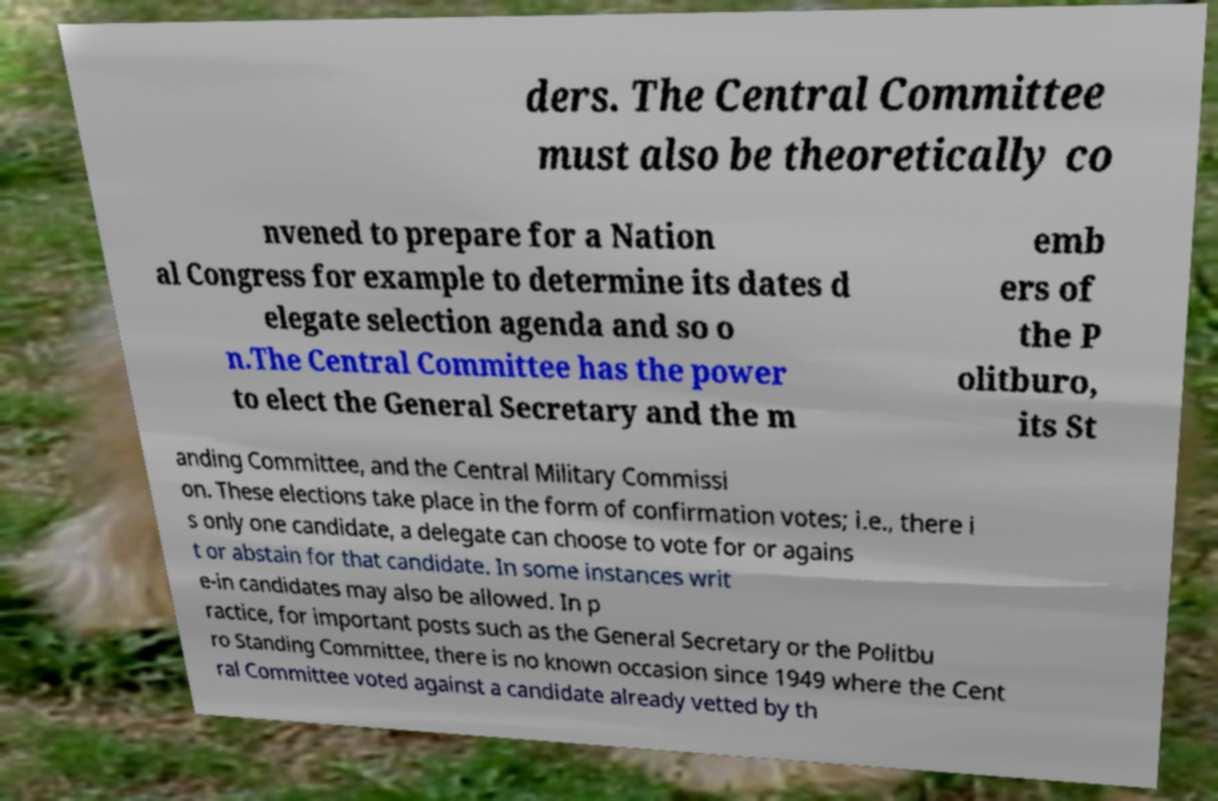I need the written content from this picture converted into text. Can you do that? ders. The Central Committee must also be theoretically co nvened to prepare for a Nation al Congress for example to determine its dates d elegate selection agenda and so o n.The Central Committee has the power to elect the General Secretary and the m emb ers of the P olitburo, its St anding Committee, and the Central Military Commissi on. These elections take place in the form of confirmation votes; i.e., there i s only one candidate, a delegate can choose to vote for or agains t or abstain for that candidate. In some instances writ e-in candidates may also be allowed. In p ractice, for important posts such as the General Secretary or the Politbu ro Standing Committee, there is no known occasion since 1949 where the Cent ral Committee voted against a candidate already vetted by th 